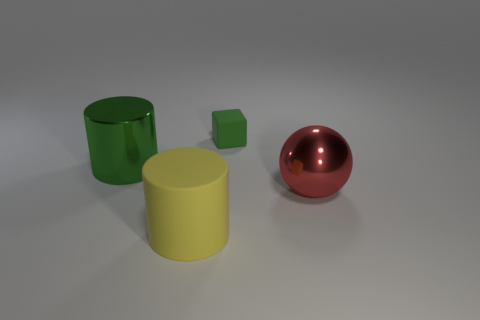Add 2 large purple shiny blocks. How many objects exist? 6 Add 1 green matte things. How many green matte things are left? 2 Add 2 small green matte cubes. How many small green matte cubes exist? 3 Subtract 1 red balls. How many objects are left? 3 Subtract 1 cylinders. How many cylinders are left? 1 Subtract all yellow blocks. Subtract all brown balls. How many blocks are left? 1 Subtract all large green rubber balls. Subtract all shiny things. How many objects are left? 2 